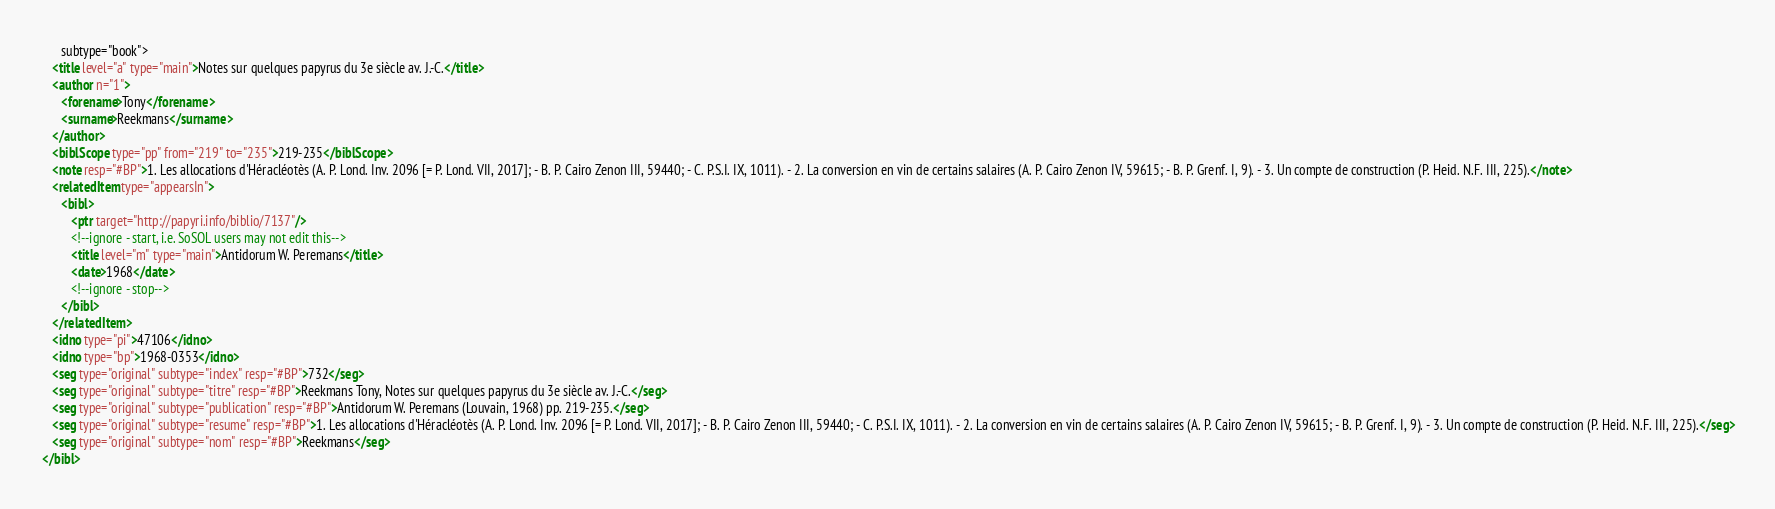<code> <loc_0><loc_0><loc_500><loc_500><_XML_>      subtype="book">
   <title level="a" type="main">Notes sur quelques papyrus du 3e siècle av. J.-C.</title>
   <author n="1">
      <forename>Tony</forename>
      <surname>Reekmans</surname>
   </author>
   <biblScope type="pp" from="219" to="235">219-235</biblScope>
   <note resp="#BP">1. Les allocations d'Héracléotès (A. P. Lond. Inv. 2096 [= P. Lond. VII, 2017]; - B. P. Cairo Zenon III, 59440; - C. P.S.I. IX, 1011). - 2. La conversion en vin de certains salaires (A. P. Cairo Zenon IV, 59615; - B. P. Grenf. I, 9). - 3. Un compte de construction (P. Heid. N.F. III, 225).</note>
   <relatedItem type="appearsIn">
      <bibl>
         <ptr target="http://papyri.info/biblio/7137"/>
         <!--ignore - start, i.e. SoSOL users may not edit this-->
         <title level="m" type="main">Antidorum W. Peremans</title>
         <date>1968</date>
         <!--ignore - stop-->
      </bibl>
   </relatedItem>
   <idno type="pi">47106</idno>
   <idno type="bp">1968-0353</idno>
   <seg type="original" subtype="index" resp="#BP">732</seg>
   <seg type="original" subtype="titre" resp="#BP">Reekmans Tony, Notes sur quelques papyrus du 3e siècle av. J.-C.</seg>
   <seg type="original" subtype="publication" resp="#BP">Antidorum W. Peremans (Louvain, 1968) pp. 219-235.</seg>
   <seg type="original" subtype="resume" resp="#BP">1. Les allocations d'Héracléotès (A. P. Lond. Inv. 2096 [= P. Lond. VII, 2017]; - B. P. Cairo Zenon III, 59440; - C. P.S.I. IX, 1011). - 2. La conversion en vin de certains salaires (A. P. Cairo Zenon IV, 59615; - B. P. Grenf. I, 9). - 3. Un compte de construction (P. Heid. N.F. III, 225).</seg>
   <seg type="original" subtype="nom" resp="#BP">Reekmans</seg>
</bibl>
</code> 